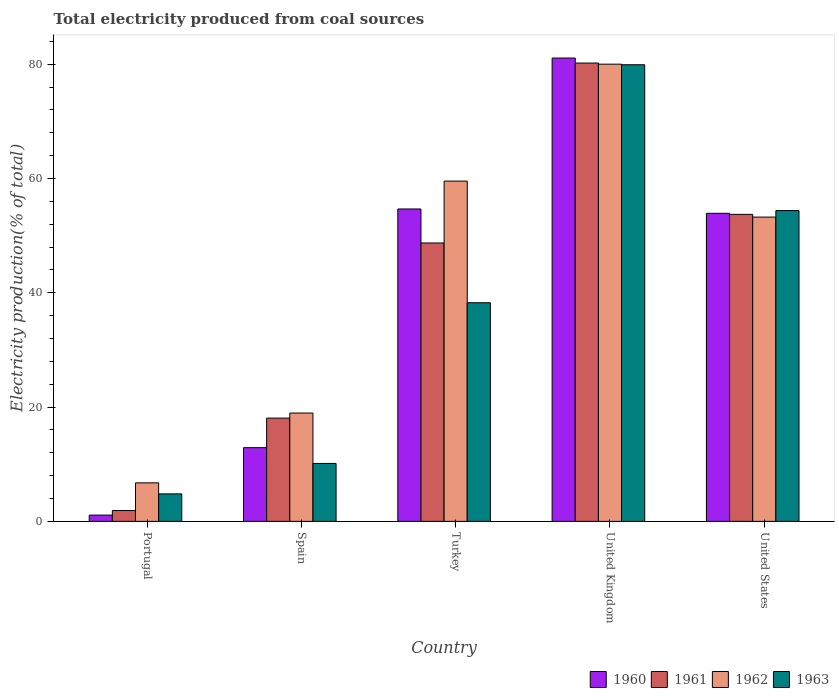How many different coloured bars are there?
Provide a succinct answer. 4. How many groups of bars are there?
Your answer should be very brief. 5. Are the number of bars on each tick of the X-axis equal?
Give a very brief answer. Yes. How many bars are there on the 2nd tick from the right?
Provide a short and direct response. 4. What is the total electricity produced in 1963 in United States?
Give a very brief answer. 54.39. Across all countries, what is the maximum total electricity produced in 1963?
Give a very brief answer. 79.91. Across all countries, what is the minimum total electricity produced in 1963?
Offer a very short reply. 4.81. In which country was the total electricity produced in 1961 maximum?
Offer a terse response. United Kingdom. What is the total total electricity produced in 1960 in the graph?
Your answer should be compact. 203.67. What is the difference between the total electricity produced in 1960 in Portugal and that in Turkey?
Provide a short and direct response. -53.57. What is the difference between the total electricity produced in 1960 in United Kingdom and the total electricity produced in 1961 in United States?
Offer a very short reply. 27.36. What is the average total electricity produced in 1961 per country?
Your answer should be very brief. 40.53. What is the difference between the total electricity produced of/in 1962 and total electricity produced of/in 1963 in United States?
Provide a short and direct response. -1.14. What is the ratio of the total electricity produced in 1963 in Spain to that in Turkey?
Ensure brevity in your answer.  0.26. Is the total electricity produced in 1962 in Spain less than that in Turkey?
Your answer should be compact. Yes. Is the difference between the total electricity produced in 1962 in Portugal and Turkey greater than the difference between the total electricity produced in 1963 in Portugal and Turkey?
Your answer should be very brief. No. What is the difference between the highest and the second highest total electricity produced in 1960?
Keep it short and to the point. 27.17. What is the difference between the highest and the lowest total electricity produced in 1960?
Give a very brief answer. 79.99. Is the sum of the total electricity produced in 1963 in Portugal and United States greater than the maximum total electricity produced in 1960 across all countries?
Give a very brief answer. No. What does the 2nd bar from the right in United Kingdom represents?
Provide a succinct answer. 1962. Is it the case that in every country, the sum of the total electricity produced in 1963 and total electricity produced in 1960 is greater than the total electricity produced in 1961?
Offer a terse response. Yes. Are all the bars in the graph horizontal?
Give a very brief answer. No. Does the graph contain any zero values?
Keep it short and to the point. No. Does the graph contain grids?
Your response must be concise. No. Where does the legend appear in the graph?
Ensure brevity in your answer.  Bottom right. How many legend labels are there?
Keep it short and to the point. 4. How are the legend labels stacked?
Provide a succinct answer. Horizontal. What is the title of the graph?
Give a very brief answer. Total electricity produced from coal sources. What is the Electricity production(% of total) in 1960 in Portugal?
Keep it short and to the point. 1.1. What is the Electricity production(% of total) in 1961 in Portugal?
Give a very brief answer. 1.89. What is the Electricity production(% of total) of 1962 in Portugal?
Provide a succinct answer. 6.74. What is the Electricity production(% of total) of 1963 in Portugal?
Your answer should be very brief. 4.81. What is the Electricity production(% of total) of 1960 in Spain?
Provide a succinct answer. 12.9. What is the Electricity production(% of total) of 1961 in Spain?
Keep it short and to the point. 18.07. What is the Electricity production(% of total) in 1962 in Spain?
Your answer should be very brief. 18.96. What is the Electricity production(% of total) of 1963 in Spain?
Your response must be concise. 10.14. What is the Electricity production(% of total) in 1960 in Turkey?
Your response must be concise. 54.67. What is the Electricity production(% of total) of 1961 in Turkey?
Your answer should be compact. 48.72. What is the Electricity production(% of total) in 1962 in Turkey?
Offer a very short reply. 59.55. What is the Electricity production(% of total) of 1963 in Turkey?
Make the answer very short. 38.26. What is the Electricity production(% of total) of 1960 in United Kingdom?
Your answer should be very brief. 81.09. What is the Electricity production(% of total) of 1961 in United Kingdom?
Provide a short and direct response. 80.21. What is the Electricity production(% of total) of 1962 in United Kingdom?
Offer a very short reply. 80.01. What is the Electricity production(% of total) of 1963 in United Kingdom?
Keep it short and to the point. 79.91. What is the Electricity production(% of total) in 1960 in United States?
Provide a short and direct response. 53.91. What is the Electricity production(% of total) in 1961 in United States?
Offer a very short reply. 53.73. What is the Electricity production(% of total) in 1962 in United States?
Your answer should be compact. 53.25. What is the Electricity production(% of total) in 1963 in United States?
Give a very brief answer. 54.39. Across all countries, what is the maximum Electricity production(% of total) in 1960?
Ensure brevity in your answer.  81.09. Across all countries, what is the maximum Electricity production(% of total) in 1961?
Offer a very short reply. 80.21. Across all countries, what is the maximum Electricity production(% of total) of 1962?
Give a very brief answer. 80.01. Across all countries, what is the maximum Electricity production(% of total) in 1963?
Your response must be concise. 79.91. Across all countries, what is the minimum Electricity production(% of total) in 1960?
Make the answer very short. 1.1. Across all countries, what is the minimum Electricity production(% of total) in 1961?
Offer a terse response. 1.89. Across all countries, what is the minimum Electricity production(% of total) of 1962?
Ensure brevity in your answer.  6.74. Across all countries, what is the minimum Electricity production(% of total) of 1963?
Ensure brevity in your answer.  4.81. What is the total Electricity production(% of total) of 1960 in the graph?
Provide a succinct answer. 203.67. What is the total Electricity production(% of total) in 1961 in the graph?
Keep it short and to the point. 202.63. What is the total Electricity production(% of total) of 1962 in the graph?
Your answer should be very brief. 218.51. What is the total Electricity production(% of total) of 1963 in the graph?
Your answer should be very brief. 187.51. What is the difference between the Electricity production(% of total) in 1960 in Portugal and that in Spain?
Provide a short and direct response. -11.8. What is the difference between the Electricity production(% of total) of 1961 in Portugal and that in Spain?
Your answer should be compact. -16.18. What is the difference between the Electricity production(% of total) in 1962 in Portugal and that in Spain?
Keep it short and to the point. -12.22. What is the difference between the Electricity production(% of total) in 1963 in Portugal and that in Spain?
Keep it short and to the point. -5.33. What is the difference between the Electricity production(% of total) in 1960 in Portugal and that in Turkey?
Make the answer very short. -53.57. What is the difference between the Electricity production(% of total) in 1961 in Portugal and that in Turkey?
Your answer should be very brief. -46.83. What is the difference between the Electricity production(% of total) of 1962 in Portugal and that in Turkey?
Give a very brief answer. -52.81. What is the difference between the Electricity production(% of total) of 1963 in Portugal and that in Turkey?
Offer a very short reply. -33.45. What is the difference between the Electricity production(% of total) in 1960 in Portugal and that in United Kingdom?
Your answer should be very brief. -79.99. What is the difference between the Electricity production(% of total) of 1961 in Portugal and that in United Kingdom?
Provide a short and direct response. -78.31. What is the difference between the Electricity production(% of total) in 1962 in Portugal and that in United Kingdom?
Your response must be concise. -73.27. What is the difference between the Electricity production(% of total) of 1963 in Portugal and that in United Kingdom?
Your answer should be very brief. -75.1. What is the difference between the Electricity production(% of total) of 1960 in Portugal and that in United States?
Your answer should be compact. -52.81. What is the difference between the Electricity production(% of total) of 1961 in Portugal and that in United States?
Provide a succinct answer. -51.84. What is the difference between the Electricity production(% of total) of 1962 in Portugal and that in United States?
Your response must be concise. -46.51. What is the difference between the Electricity production(% of total) of 1963 in Portugal and that in United States?
Provide a short and direct response. -49.58. What is the difference between the Electricity production(% of total) of 1960 in Spain and that in Turkey?
Provide a succinct answer. -41.77. What is the difference between the Electricity production(% of total) in 1961 in Spain and that in Turkey?
Make the answer very short. -30.65. What is the difference between the Electricity production(% of total) of 1962 in Spain and that in Turkey?
Provide a succinct answer. -40.59. What is the difference between the Electricity production(% of total) of 1963 in Spain and that in Turkey?
Your answer should be very brief. -28.13. What is the difference between the Electricity production(% of total) of 1960 in Spain and that in United Kingdom?
Make the answer very short. -68.19. What is the difference between the Electricity production(% of total) of 1961 in Spain and that in United Kingdom?
Your answer should be compact. -62.14. What is the difference between the Electricity production(% of total) in 1962 in Spain and that in United Kingdom?
Your answer should be compact. -61.06. What is the difference between the Electricity production(% of total) of 1963 in Spain and that in United Kingdom?
Provide a succinct answer. -69.78. What is the difference between the Electricity production(% of total) in 1960 in Spain and that in United States?
Keep it short and to the point. -41.01. What is the difference between the Electricity production(% of total) in 1961 in Spain and that in United States?
Ensure brevity in your answer.  -35.66. What is the difference between the Electricity production(% of total) in 1962 in Spain and that in United States?
Your answer should be compact. -34.29. What is the difference between the Electricity production(% of total) in 1963 in Spain and that in United States?
Ensure brevity in your answer.  -44.25. What is the difference between the Electricity production(% of total) in 1960 in Turkey and that in United Kingdom?
Your response must be concise. -26.41. What is the difference between the Electricity production(% of total) in 1961 in Turkey and that in United Kingdom?
Provide a short and direct response. -31.49. What is the difference between the Electricity production(% of total) in 1962 in Turkey and that in United Kingdom?
Make the answer very short. -20.46. What is the difference between the Electricity production(% of total) of 1963 in Turkey and that in United Kingdom?
Offer a terse response. -41.65. What is the difference between the Electricity production(% of total) of 1960 in Turkey and that in United States?
Give a very brief answer. 0.76. What is the difference between the Electricity production(% of total) of 1961 in Turkey and that in United States?
Give a very brief answer. -5.01. What is the difference between the Electricity production(% of total) of 1962 in Turkey and that in United States?
Your answer should be compact. 6.3. What is the difference between the Electricity production(% of total) in 1963 in Turkey and that in United States?
Offer a very short reply. -16.13. What is the difference between the Electricity production(% of total) in 1960 in United Kingdom and that in United States?
Give a very brief answer. 27.17. What is the difference between the Electricity production(% of total) of 1961 in United Kingdom and that in United States?
Provide a short and direct response. 26.48. What is the difference between the Electricity production(% of total) of 1962 in United Kingdom and that in United States?
Offer a terse response. 26.76. What is the difference between the Electricity production(% of total) in 1963 in United Kingdom and that in United States?
Your answer should be very brief. 25.52. What is the difference between the Electricity production(% of total) in 1960 in Portugal and the Electricity production(% of total) in 1961 in Spain?
Your answer should be very brief. -16.97. What is the difference between the Electricity production(% of total) of 1960 in Portugal and the Electricity production(% of total) of 1962 in Spain?
Ensure brevity in your answer.  -17.86. What is the difference between the Electricity production(% of total) of 1960 in Portugal and the Electricity production(% of total) of 1963 in Spain?
Your answer should be very brief. -9.04. What is the difference between the Electricity production(% of total) of 1961 in Portugal and the Electricity production(% of total) of 1962 in Spain?
Offer a very short reply. -17.06. What is the difference between the Electricity production(% of total) in 1961 in Portugal and the Electricity production(% of total) in 1963 in Spain?
Provide a succinct answer. -8.24. What is the difference between the Electricity production(% of total) in 1962 in Portugal and the Electricity production(% of total) in 1963 in Spain?
Offer a very short reply. -3.4. What is the difference between the Electricity production(% of total) in 1960 in Portugal and the Electricity production(% of total) in 1961 in Turkey?
Provide a succinct answer. -47.62. What is the difference between the Electricity production(% of total) in 1960 in Portugal and the Electricity production(% of total) in 1962 in Turkey?
Ensure brevity in your answer.  -58.45. What is the difference between the Electricity production(% of total) of 1960 in Portugal and the Electricity production(% of total) of 1963 in Turkey?
Provide a succinct answer. -37.16. What is the difference between the Electricity production(% of total) of 1961 in Portugal and the Electricity production(% of total) of 1962 in Turkey?
Your answer should be very brief. -57.66. What is the difference between the Electricity production(% of total) of 1961 in Portugal and the Electricity production(% of total) of 1963 in Turkey?
Provide a short and direct response. -36.37. What is the difference between the Electricity production(% of total) of 1962 in Portugal and the Electricity production(% of total) of 1963 in Turkey?
Keep it short and to the point. -31.52. What is the difference between the Electricity production(% of total) in 1960 in Portugal and the Electricity production(% of total) in 1961 in United Kingdom?
Make the answer very short. -79.11. What is the difference between the Electricity production(% of total) of 1960 in Portugal and the Electricity production(% of total) of 1962 in United Kingdom?
Provide a succinct answer. -78.92. What is the difference between the Electricity production(% of total) of 1960 in Portugal and the Electricity production(% of total) of 1963 in United Kingdom?
Offer a very short reply. -78.82. What is the difference between the Electricity production(% of total) of 1961 in Portugal and the Electricity production(% of total) of 1962 in United Kingdom?
Offer a terse response. -78.12. What is the difference between the Electricity production(% of total) in 1961 in Portugal and the Electricity production(% of total) in 1963 in United Kingdom?
Your answer should be very brief. -78.02. What is the difference between the Electricity production(% of total) in 1962 in Portugal and the Electricity production(% of total) in 1963 in United Kingdom?
Ensure brevity in your answer.  -73.17. What is the difference between the Electricity production(% of total) in 1960 in Portugal and the Electricity production(% of total) in 1961 in United States?
Provide a succinct answer. -52.63. What is the difference between the Electricity production(% of total) of 1960 in Portugal and the Electricity production(% of total) of 1962 in United States?
Give a very brief answer. -52.15. What is the difference between the Electricity production(% of total) of 1960 in Portugal and the Electricity production(% of total) of 1963 in United States?
Your answer should be very brief. -53.29. What is the difference between the Electricity production(% of total) of 1961 in Portugal and the Electricity production(% of total) of 1962 in United States?
Your answer should be very brief. -51.36. What is the difference between the Electricity production(% of total) of 1961 in Portugal and the Electricity production(% of total) of 1963 in United States?
Provide a succinct answer. -52.5. What is the difference between the Electricity production(% of total) in 1962 in Portugal and the Electricity production(% of total) in 1963 in United States?
Provide a succinct answer. -47.65. What is the difference between the Electricity production(% of total) in 1960 in Spain and the Electricity production(% of total) in 1961 in Turkey?
Offer a terse response. -35.82. What is the difference between the Electricity production(% of total) of 1960 in Spain and the Electricity production(% of total) of 1962 in Turkey?
Provide a succinct answer. -46.65. What is the difference between the Electricity production(% of total) in 1960 in Spain and the Electricity production(% of total) in 1963 in Turkey?
Provide a succinct answer. -25.36. What is the difference between the Electricity production(% of total) of 1961 in Spain and the Electricity production(% of total) of 1962 in Turkey?
Provide a short and direct response. -41.48. What is the difference between the Electricity production(% of total) in 1961 in Spain and the Electricity production(% of total) in 1963 in Turkey?
Keep it short and to the point. -20.19. What is the difference between the Electricity production(% of total) in 1962 in Spain and the Electricity production(% of total) in 1963 in Turkey?
Offer a very short reply. -19.31. What is the difference between the Electricity production(% of total) of 1960 in Spain and the Electricity production(% of total) of 1961 in United Kingdom?
Your answer should be very brief. -67.31. What is the difference between the Electricity production(% of total) of 1960 in Spain and the Electricity production(% of total) of 1962 in United Kingdom?
Your answer should be compact. -67.12. What is the difference between the Electricity production(% of total) of 1960 in Spain and the Electricity production(% of total) of 1963 in United Kingdom?
Offer a very short reply. -67.02. What is the difference between the Electricity production(% of total) in 1961 in Spain and the Electricity production(% of total) in 1962 in United Kingdom?
Provide a short and direct response. -61.94. What is the difference between the Electricity production(% of total) in 1961 in Spain and the Electricity production(% of total) in 1963 in United Kingdom?
Give a very brief answer. -61.84. What is the difference between the Electricity production(% of total) of 1962 in Spain and the Electricity production(% of total) of 1963 in United Kingdom?
Provide a succinct answer. -60.96. What is the difference between the Electricity production(% of total) of 1960 in Spain and the Electricity production(% of total) of 1961 in United States?
Ensure brevity in your answer.  -40.83. What is the difference between the Electricity production(% of total) of 1960 in Spain and the Electricity production(% of total) of 1962 in United States?
Keep it short and to the point. -40.35. What is the difference between the Electricity production(% of total) of 1960 in Spain and the Electricity production(% of total) of 1963 in United States?
Give a very brief answer. -41.49. What is the difference between the Electricity production(% of total) in 1961 in Spain and the Electricity production(% of total) in 1962 in United States?
Your answer should be compact. -35.18. What is the difference between the Electricity production(% of total) in 1961 in Spain and the Electricity production(% of total) in 1963 in United States?
Ensure brevity in your answer.  -36.32. What is the difference between the Electricity production(% of total) of 1962 in Spain and the Electricity production(% of total) of 1963 in United States?
Give a very brief answer. -35.43. What is the difference between the Electricity production(% of total) in 1960 in Turkey and the Electricity production(% of total) in 1961 in United Kingdom?
Your response must be concise. -25.54. What is the difference between the Electricity production(% of total) in 1960 in Turkey and the Electricity production(% of total) in 1962 in United Kingdom?
Your answer should be very brief. -25.34. What is the difference between the Electricity production(% of total) of 1960 in Turkey and the Electricity production(% of total) of 1963 in United Kingdom?
Your response must be concise. -25.24. What is the difference between the Electricity production(% of total) in 1961 in Turkey and the Electricity production(% of total) in 1962 in United Kingdom?
Give a very brief answer. -31.29. What is the difference between the Electricity production(% of total) in 1961 in Turkey and the Electricity production(% of total) in 1963 in United Kingdom?
Offer a very short reply. -31.19. What is the difference between the Electricity production(% of total) in 1962 in Turkey and the Electricity production(% of total) in 1963 in United Kingdom?
Make the answer very short. -20.36. What is the difference between the Electricity production(% of total) of 1960 in Turkey and the Electricity production(% of total) of 1961 in United States?
Your answer should be compact. 0.94. What is the difference between the Electricity production(% of total) in 1960 in Turkey and the Electricity production(% of total) in 1962 in United States?
Your answer should be very brief. 1.42. What is the difference between the Electricity production(% of total) in 1960 in Turkey and the Electricity production(% of total) in 1963 in United States?
Provide a short and direct response. 0.28. What is the difference between the Electricity production(% of total) of 1961 in Turkey and the Electricity production(% of total) of 1962 in United States?
Your response must be concise. -4.53. What is the difference between the Electricity production(% of total) in 1961 in Turkey and the Electricity production(% of total) in 1963 in United States?
Provide a succinct answer. -5.67. What is the difference between the Electricity production(% of total) of 1962 in Turkey and the Electricity production(% of total) of 1963 in United States?
Your response must be concise. 5.16. What is the difference between the Electricity production(% of total) in 1960 in United Kingdom and the Electricity production(% of total) in 1961 in United States?
Give a very brief answer. 27.36. What is the difference between the Electricity production(% of total) of 1960 in United Kingdom and the Electricity production(% of total) of 1962 in United States?
Your answer should be compact. 27.84. What is the difference between the Electricity production(% of total) of 1960 in United Kingdom and the Electricity production(% of total) of 1963 in United States?
Give a very brief answer. 26.7. What is the difference between the Electricity production(% of total) in 1961 in United Kingdom and the Electricity production(% of total) in 1962 in United States?
Keep it short and to the point. 26.96. What is the difference between the Electricity production(% of total) in 1961 in United Kingdom and the Electricity production(% of total) in 1963 in United States?
Give a very brief answer. 25.82. What is the difference between the Electricity production(% of total) in 1962 in United Kingdom and the Electricity production(% of total) in 1963 in United States?
Your answer should be compact. 25.62. What is the average Electricity production(% of total) in 1960 per country?
Your response must be concise. 40.73. What is the average Electricity production(% of total) in 1961 per country?
Your response must be concise. 40.53. What is the average Electricity production(% of total) in 1962 per country?
Your answer should be very brief. 43.7. What is the average Electricity production(% of total) of 1963 per country?
Give a very brief answer. 37.5. What is the difference between the Electricity production(% of total) in 1960 and Electricity production(% of total) in 1961 in Portugal?
Provide a succinct answer. -0.8. What is the difference between the Electricity production(% of total) in 1960 and Electricity production(% of total) in 1962 in Portugal?
Provide a succinct answer. -5.64. What is the difference between the Electricity production(% of total) in 1960 and Electricity production(% of total) in 1963 in Portugal?
Keep it short and to the point. -3.71. What is the difference between the Electricity production(% of total) in 1961 and Electricity production(% of total) in 1962 in Portugal?
Your response must be concise. -4.85. What is the difference between the Electricity production(% of total) in 1961 and Electricity production(% of total) in 1963 in Portugal?
Make the answer very short. -2.91. What is the difference between the Electricity production(% of total) in 1962 and Electricity production(% of total) in 1963 in Portugal?
Give a very brief answer. 1.93. What is the difference between the Electricity production(% of total) in 1960 and Electricity production(% of total) in 1961 in Spain?
Your answer should be very brief. -5.17. What is the difference between the Electricity production(% of total) in 1960 and Electricity production(% of total) in 1962 in Spain?
Give a very brief answer. -6.06. What is the difference between the Electricity production(% of total) of 1960 and Electricity production(% of total) of 1963 in Spain?
Make the answer very short. 2.76. What is the difference between the Electricity production(% of total) in 1961 and Electricity production(% of total) in 1962 in Spain?
Ensure brevity in your answer.  -0.88. What is the difference between the Electricity production(% of total) of 1961 and Electricity production(% of total) of 1963 in Spain?
Offer a terse response. 7.94. What is the difference between the Electricity production(% of total) in 1962 and Electricity production(% of total) in 1963 in Spain?
Your answer should be very brief. 8.82. What is the difference between the Electricity production(% of total) in 1960 and Electricity production(% of total) in 1961 in Turkey?
Your answer should be compact. 5.95. What is the difference between the Electricity production(% of total) of 1960 and Electricity production(% of total) of 1962 in Turkey?
Provide a succinct answer. -4.88. What is the difference between the Electricity production(% of total) of 1960 and Electricity production(% of total) of 1963 in Turkey?
Offer a terse response. 16.41. What is the difference between the Electricity production(% of total) of 1961 and Electricity production(% of total) of 1962 in Turkey?
Make the answer very short. -10.83. What is the difference between the Electricity production(% of total) of 1961 and Electricity production(% of total) of 1963 in Turkey?
Provide a short and direct response. 10.46. What is the difference between the Electricity production(% of total) of 1962 and Electricity production(% of total) of 1963 in Turkey?
Provide a short and direct response. 21.29. What is the difference between the Electricity production(% of total) in 1960 and Electricity production(% of total) in 1961 in United Kingdom?
Ensure brevity in your answer.  0.88. What is the difference between the Electricity production(% of total) in 1960 and Electricity production(% of total) in 1962 in United Kingdom?
Ensure brevity in your answer.  1.07. What is the difference between the Electricity production(% of total) in 1960 and Electricity production(% of total) in 1963 in United Kingdom?
Your answer should be compact. 1.17. What is the difference between the Electricity production(% of total) in 1961 and Electricity production(% of total) in 1962 in United Kingdom?
Your answer should be compact. 0.19. What is the difference between the Electricity production(% of total) in 1961 and Electricity production(% of total) in 1963 in United Kingdom?
Offer a very short reply. 0.29. What is the difference between the Electricity production(% of total) in 1962 and Electricity production(% of total) in 1963 in United Kingdom?
Keep it short and to the point. 0.1. What is the difference between the Electricity production(% of total) in 1960 and Electricity production(% of total) in 1961 in United States?
Make the answer very short. 0.18. What is the difference between the Electricity production(% of total) of 1960 and Electricity production(% of total) of 1962 in United States?
Give a very brief answer. 0.66. What is the difference between the Electricity production(% of total) in 1960 and Electricity production(% of total) in 1963 in United States?
Give a very brief answer. -0.48. What is the difference between the Electricity production(% of total) in 1961 and Electricity production(% of total) in 1962 in United States?
Keep it short and to the point. 0.48. What is the difference between the Electricity production(% of total) of 1961 and Electricity production(% of total) of 1963 in United States?
Give a very brief answer. -0.66. What is the difference between the Electricity production(% of total) of 1962 and Electricity production(% of total) of 1963 in United States?
Keep it short and to the point. -1.14. What is the ratio of the Electricity production(% of total) in 1960 in Portugal to that in Spain?
Your answer should be very brief. 0.09. What is the ratio of the Electricity production(% of total) of 1961 in Portugal to that in Spain?
Your answer should be compact. 0.1. What is the ratio of the Electricity production(% of total) of 1962 in Portugal to that in Spain?
Ensure brevity in your answer.  0.36. What is the ratio of the Electricity production(% of total) in 1963 in Portugal to that in Spain?
Ensure brevity in your answer.  0.47. What is the ratio of the Electricity production(% of total) of 1960 in Portugal to that in Turkey?
Provide a short and direct response. 0.02. What is the ratio of the Electricity production(% of total) of 1961 in Portugal to that in Turkey?
Provide a succinct answer. 0.04. What is the ratio of the Electricity production(% of total) of 1962 in Portugal to that in Turkey?
Ensure brevity in your answer.  0.11. What is the ratio of the Electricity production(% of total) in 1963 in Portugal to that in Turkey?
Ensure brevity in your answer.  0.13. What is the ratio of the Electricity production(% of total) of 1960 in Portugal to that in United Kingdom?
Provide a short and direct response. 0.01. What is the ratio of the Electricity production(% of total) in 1961 in Portugal to that in United Kingdom?
Your answer should be very brief. 0.02. What is the ratio of the Electricity production(% of total) in 1962 in Portugal to that in United Kingdom?
Offer a terse response. 0.08. What is the ratio of the Electricity production(% of total) of 1963 in Portugal to that in United Kingdom?
Ensure brevity in your answer.  0.06. What is the ratio of the Electricity production(% of total) in 1960 in Portugal to that in United States?
Give a very brief answer. 0.02. What is the ratio of the Electricity production(% of total) in 1961 in Portugal to that in United States?
Give a very brief answer. 0.04. What is the ratio of the Electricity production(% of total) in 1962 in Portugal to that in United States?
Offer a terse response. 0.13. What is the ratio of the Electricity production(% of total) in 1963 in Portugal to that in United States?
Your answer should be very brief. 0.09. What is the ratio of the Electricity production(% of total) in 1960 in Spain to that in Turkey?
Offer a terse response. 0.24. What is the ratio of the Electricity production(% of total) in 1961 in Spain to that in Turkey?
Your response must be concise. 0.37. What is the ratio of the Electricity production(% of total) in 1962 in Spain to that in Turkey?
Keep it short and to the point. 0.32. What is the ratio of the Electricity production(% of total) of 1963 in Spain to that in Turkey?
Offer a very short reply. 0.26. What is the ratio of the Electricity production(% of total) in 1960 in Spain to that in United Kingdom?
Provide a short and direct response. 0.16. What is the ratio of the Electricity production(% of total) of 1961 in Spain to that in United Kingdom?
Offer a very short reply. 0.23. What is the ratio of the Electricity production(% of total) of 1962 in Spain to that in United Kingdom?
Offer a very short reply. 0.24. What is the ratio of the Electricity production(% of total) of 1963 in Spain to that in United Kingdom?
Give a very brief answer. 0.13. What is the ratio of the Electricity production(% of total) in 1960 in Spain to that in United States?
Provide a short and direct response. 0.24. What is the ratio of the Electricity production(% of total) in 1961 in Spain to that in United States?
Give a very brief answer. 0.34. What is the ratio of the Electricity production(% of total) of 1962 in Spain to that in United States?
Your answer should be very brief. 0.36. What is the ratio of the Electricity production(% of total) of 1963 in Spain to that in United States?
Keep it short and to the point. 0.19. What is the ratio of the Electricity production(% of total) of 1960 in Turkey to that in United Kingdom?
Your answer should be very brief. 0.67. What is the ratio of the Electricity production(% of total) in 1961 in Turkey to that in United Kingdom?
Give a very brief answer. 0.61. What is the ratio of the Electricity production(% of total) of 1962 in Turkey to that in United Kingdom?
Offer a terse response. 0.74. What is the ratio of the Electricity production(% of total) of 1963 in Turkey to that in United Kingdom?
Make the answer very short. 0.48. What is the ratio of the Electricity production(% of total) in 1960 in Turkey to that in United States?
Give a very brief answer. 1.01. What is the ratio of the Electricity production(% of total) of 1961 in Turkey to that in United States?
Provide a short and direct response. 0.91. What is the ratio of the Electricity production(% of total) in 1962 in Turkey to that in United States?
Offer a very short reply. 1.12. What is the ratio of the Electricity production(% of total) in 1963 in Turkey to that in United States?
Offer a very short reply. 0.7. What is the ratio of the Electricity production(% of total) in 1960 in United Kingdom to that in United States?
Offer a terse response. 1.5. What is the ratio of the Electricity production(% of total) in 1961 in United Kingdom to that in United States?
Keep it short and to the point. 1.49. What is the ratio of the Electricity production(% of total) of 1962 in United Kingdom to that in United States?
Your answer should be compact. 1.5. What is the ratio of the Electricity production(% of total) in 1963 in United Kingdom to that in United States?
Provide a short and direct response. 1.47. What is the difference between the highest and the second highest Electricity production(% of total) in 1960?
Your answer should be compact. 26.41. What is the difference between the highest and the second highest Electricity production(% of total) in 1961?
Keep it short and to the point. 26.48. What is the difference between the highest and the second highest Electricity production(% of total) in 1962?
Provide a succinct answer. 20.46. What is the difference between the highest and the second highest Electricity production(% of total) of 1963?
Your answer should be compact. 25.52. What is the difference between the highest and the lowest Electricity production(% of total) in 1960?
Ensure brevity in your answer.  79.99. What is the difference between the highest and the lowest Electricity production(% of total) of 1961?
Offer a terse response. 78.31. What is the difference between the highest and the lowest Electricity production(% of total) in 1962?
Make the answer very short. 73.27. What is the difference between the highest and the lowest Electricity production(% of total) of 1963?
Your answer should be very brief. 75.1. 